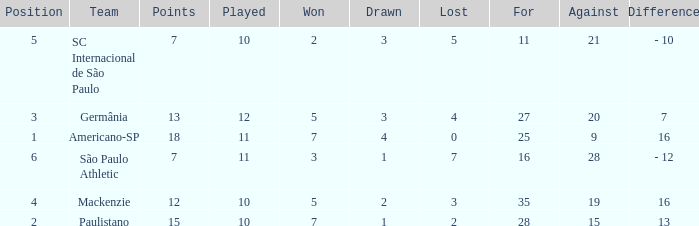Name the least for when played is 12 27.0. 